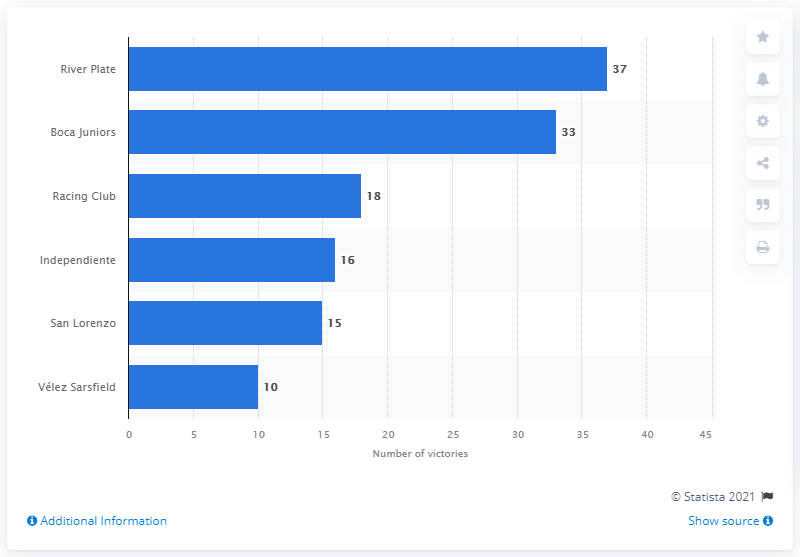List a handful of essential elements in this visual. Boca Juniors' biggest rival is River Plate, as stated. Boca Juniors is the second most successful soccer team in Argentina. 